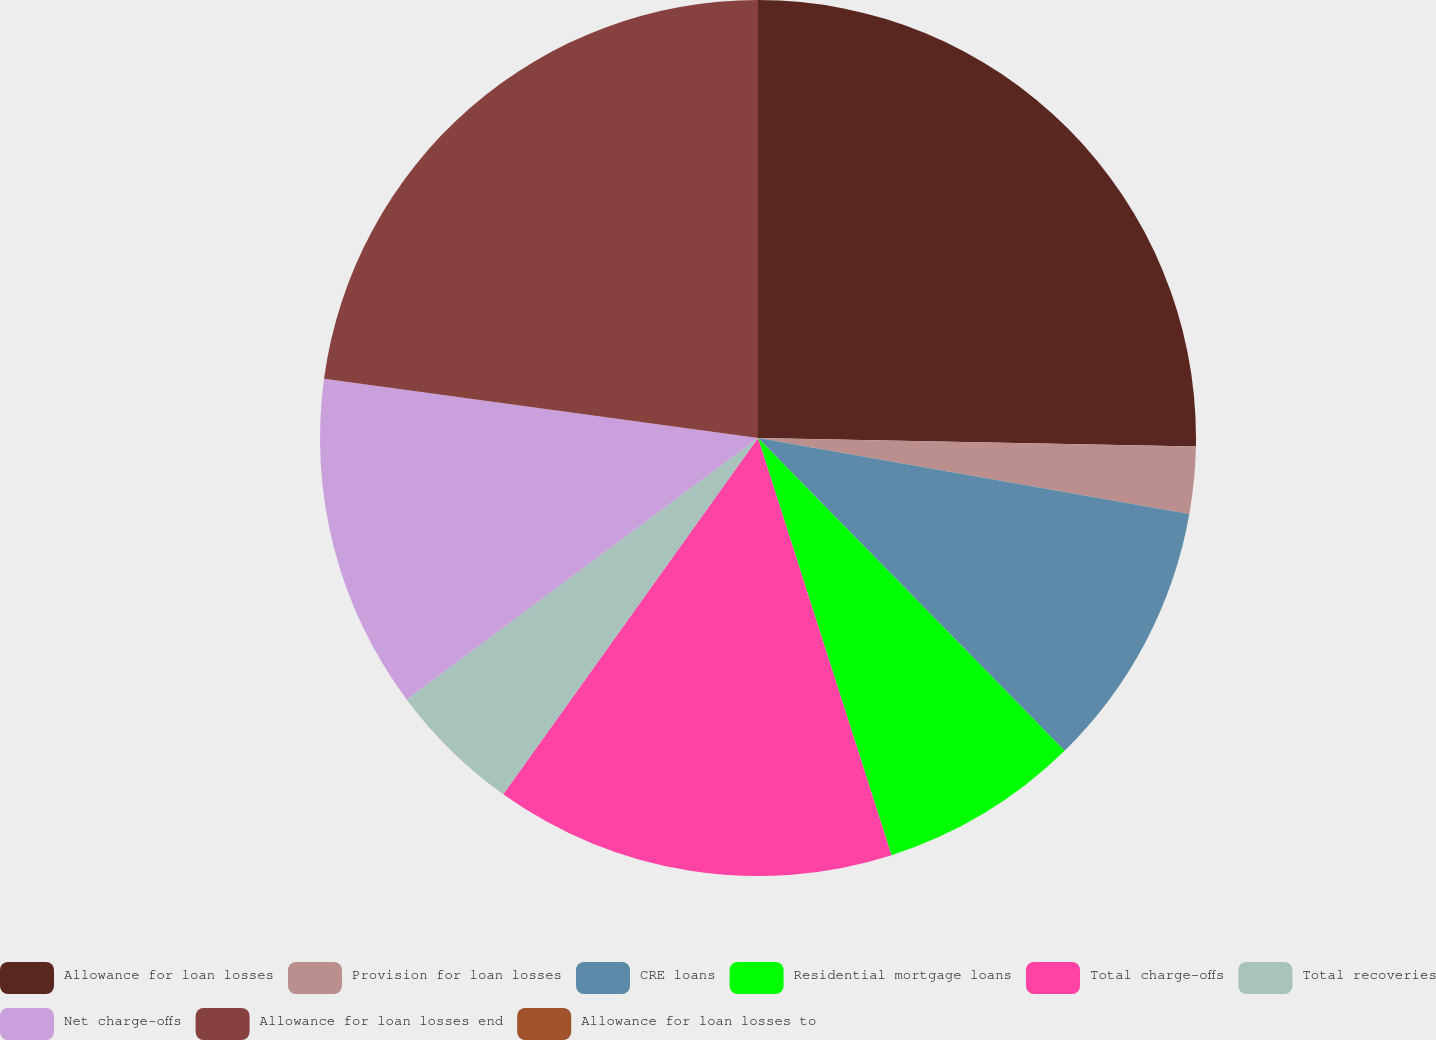Convert chart. <chart><loc_0><loc_0><loc_500><loc_500><pie_chart><fcel>Allowance for loan losses<fcel>Provision for loan losses<fcel>CRE loans<fcel>Residential mortgage loans<fcel>Total charge-offs<fcel>Total recoveries<fcel>Net charge-offs<fcel>Allowance for loan losses end<fcel>Allowance for loan losses to<nl><fcel>25.31%<fcel>2.47%<fcel>9.88%<fcel>7.41%<fcel>14.81%<fcel>4.94%<fcel>12.34%<fcel>22.84%<fcel>0.0%<nl></chart> 